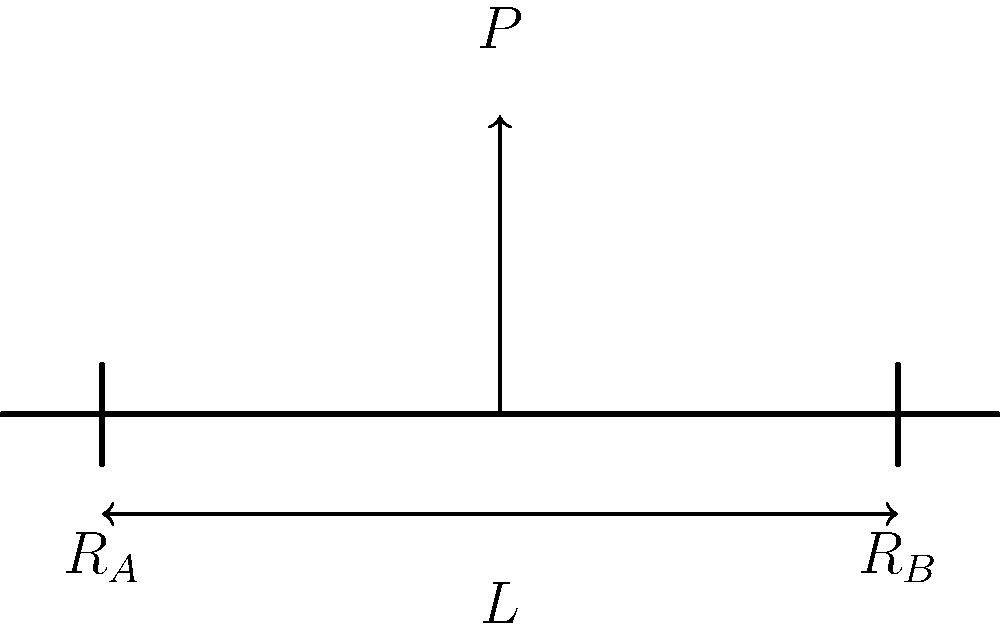During a late-night study session fueled by your favorite energy drink, you come across a problem about a simple beam bridge. The beam spans a length $L$ and is subjected to a point load $P$ at its center. If the maximum bending moment in the beam is given by $M_{max} = \frac{PL}{4}$, what is the load-bearing capacity of the beam if its allowable bending stress is $\sigma_{allow}$ and its section modulus is $S$? Let's approach this step-by-step:

1) The maximum bending moment for a simply supported beam with a central point load is given as:

   $M_{max} = \frac{PL}{4}$

2) We know that the maximum stress in a beam is related to the bending moment and section modulus by:

   $\sigma_{max} = \frac{M_{max}}{S}$

3) For safe design, we want the maximum stress to be less than or equal to the allowable stress:

   $\sigma_{max} \leq \sigma_{allow}$

4) Substituting the expression for $M_{max}$:

   $\frac{PL}{4S} \leq \sigma_{allow}$

5) To find the maximum load-bearing capacity, we can make this an equality:

   $\frac{PL}{4S} = \sigma_{allow}$

6) Solving for $P$:

   $P = \frac{4S\sigma_{allow}}{L}$

This gives us the maximum load the beam can safely bear.
Answer: $P = \frac{4S\sigma_{allow}}{L}$ 